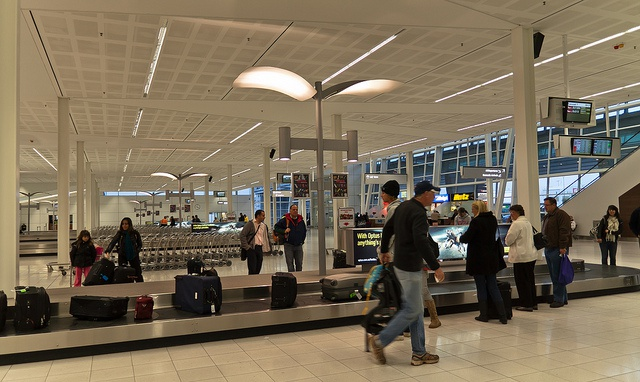Describe the objects in this image and their specific colors. I can see people in tan, black, gray, and maroon tones, people in tan, black, gray, and maroon tones, people in tan, black, and gray tones, people in tan, black, maroon, navy, and gray tones, and people in tan, black, gray, and darkgray tones in this image. 